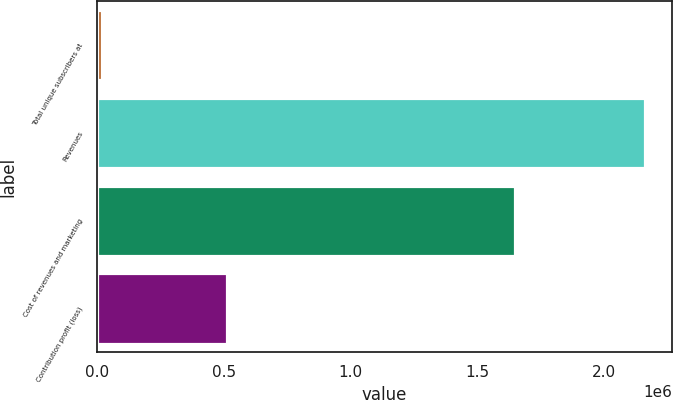Convert chart. <chart><loc_0><loc_0><loc_500><loc_500><bar_chart><fcel>Total unique subscribers at<fcel>Revenues<fcel>Cost of revenues and marketing<fcel>Contribution profit (loss)<nl><fcel>20010<fcel>2.16262e+06<fcel>1.65119e+06<fcel>511431<nl></chart> 